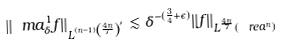Convert formula to latex. <formula><loc_0><loc_0><loc_500><loc_500>\| \ m a ^ { 1 } _ { \delta } f \| _ { L ^ { ( n - 1 ) \left ( \frac { 4 n } { 7 } \right ) ^ { \prime } } } \lesssim \delta ^ { - ( \frac { 3 } { 4 } + \epsilon ) } \| f \| _ { L ^ { \frac { 4 n } { 7 } } ( \ r e a ^ { n } ) }</formula> 